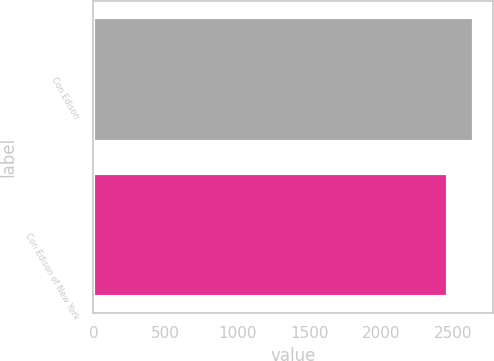Convert chart to OTSL. <chart><loc_0><loc_0><loc_500><loc_500><bar_chart><fcel>Con Edison<fcel>Con Edison of New York<nl><fcel>2642<fcel>2461<nl></chart> 